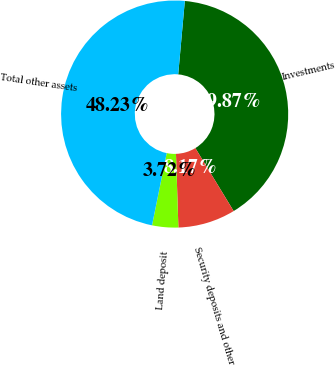Convert chart to OTSL. <chart><loc_0><loc_0><loc_500><loc_500><pie_chart><fcel>Investments<fcel>Security deposits and other<fcel>Land deposit<fcel>Total other assets<nl><fcel>39.87%<fcel>8.17%<fcel>3.72%<fcel>48.23%<nl></chart> 